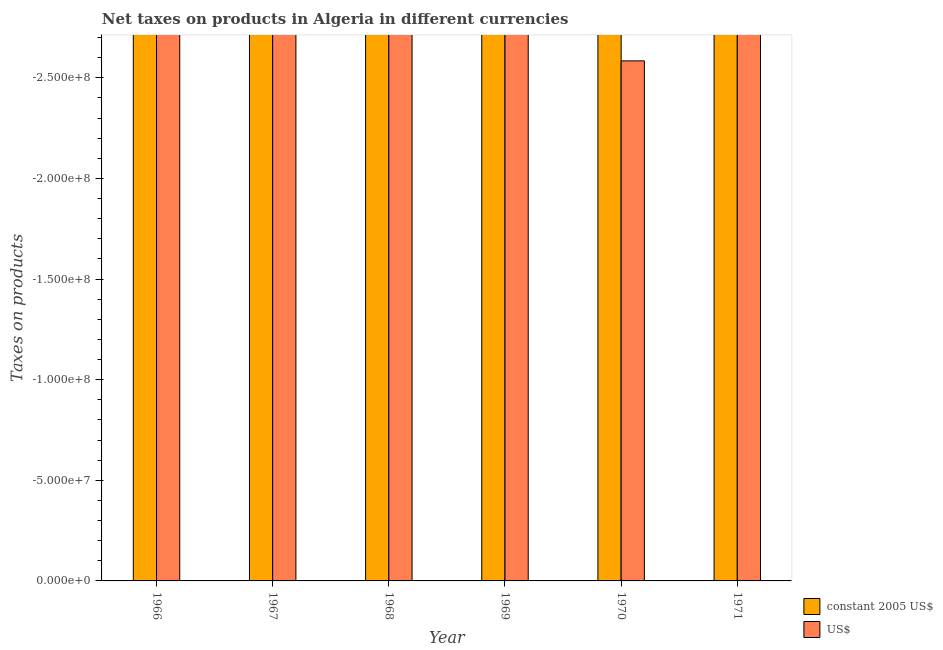Are the number of bars on each tick of the X-axis equal?
Keep it short and to the point. Yes. What is the label of the 4th group of bars from the left?
Keep it short and to the point. 1969. In how many cases, is the number of bars for a given year not equal to the number of legend labels?
Provide a short and direct response. 6. What is the net taxes in constant 2005 us$ in 1970?
Make the answer very short. 0. What is the total net taxes in us$ in the graph?
Provide a succinct answer. 0. What is the average net taxes in us$ per year?
Keep it short and to the point. 0. In how many years, is the net taxes in us$ greater than -190000000 units?
Make the answer very short. 0. How many bars are there?
Make the answer very short. 0. What is the difference between two consecutive major ticks on the Y-axis?
Give a very brief answer. 5.00e+07. Does the graph contain any zero values?
Provide a succinct answer. Yes. Does the graph contain grids?
Your answer should be compact. No. Where does the legend appear in the graph?
Offer a very short reply. Bottom right. How many legend labels are there?
Offer a very short reply. 2. What is the title of the graph?
Provide a short and direct response. Net taxes on products in Algeria in different currencies. Does "Lower secondary education" appear as one of the legend labels in the graph?
Offer a very short reply. No. What is the label or title of the X-axis?
Provide a succinct answer. Year. What is the label or title of the Y-axis?
Make the answer very short. Taxes on products. What is the Taxes on products of constant 2005 US$ in 1967?
Your response must be concise. 0. What is the Taxes on products of constant 2005 US$ in 1968?
Your response must be concise. 0. What is the Taxes on products in US$ in 1968?
Keep it short and to the point. 0. What is the Taxes on products in constant 2005 US$ in 1969?
Your answer should be very brief. 0. What is the Taxes on products of constant 2005 US$ in 1971?
Your answer should be compact. 0. What is the Taxes on products in US$ in 1971?
Provide a short and direct response. 0. What is the total Taxes on products in constant 2005 US$ in the graph?
Provide a succinct answer. 0. What is the total Taxes on products in US$ in the graph?
Ensure brevity in your answer.  0. What is the average Taxes on products of constant 2005 US$ per year?
Provide a short and direct response. 0. What is the average Taxes on products in US$ per year?
Give a very brief answer. 0. 